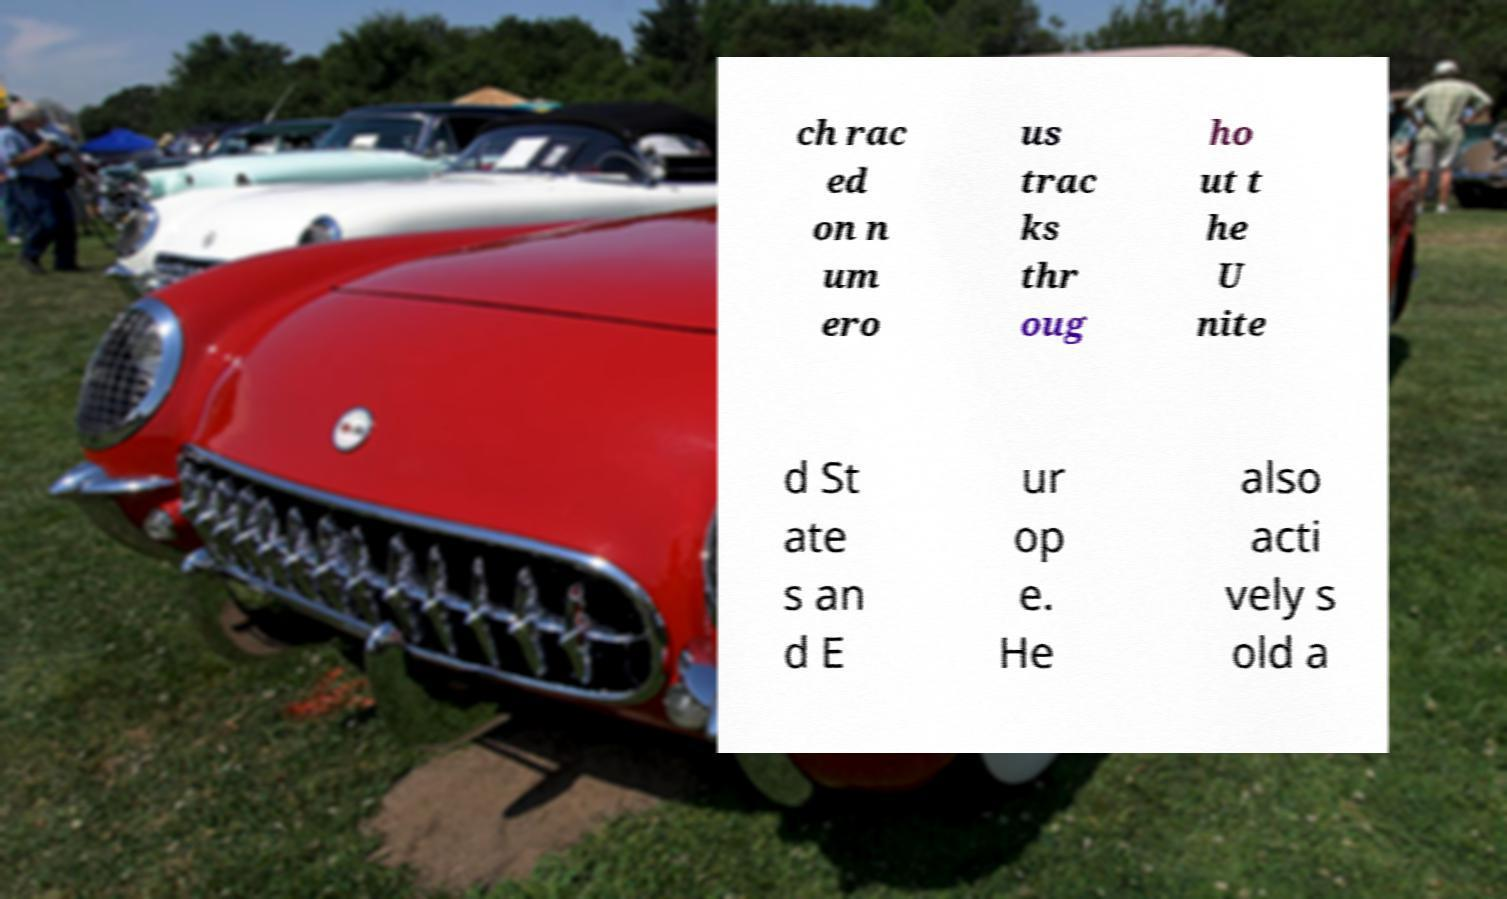For documentation purposes, I need the text within this image transcribed. Could you provide that? ch rac ed on n um ero us trac ks thr oug ho ut t he U nite d St ate s an d E ur op e. He also acti vely s old a 